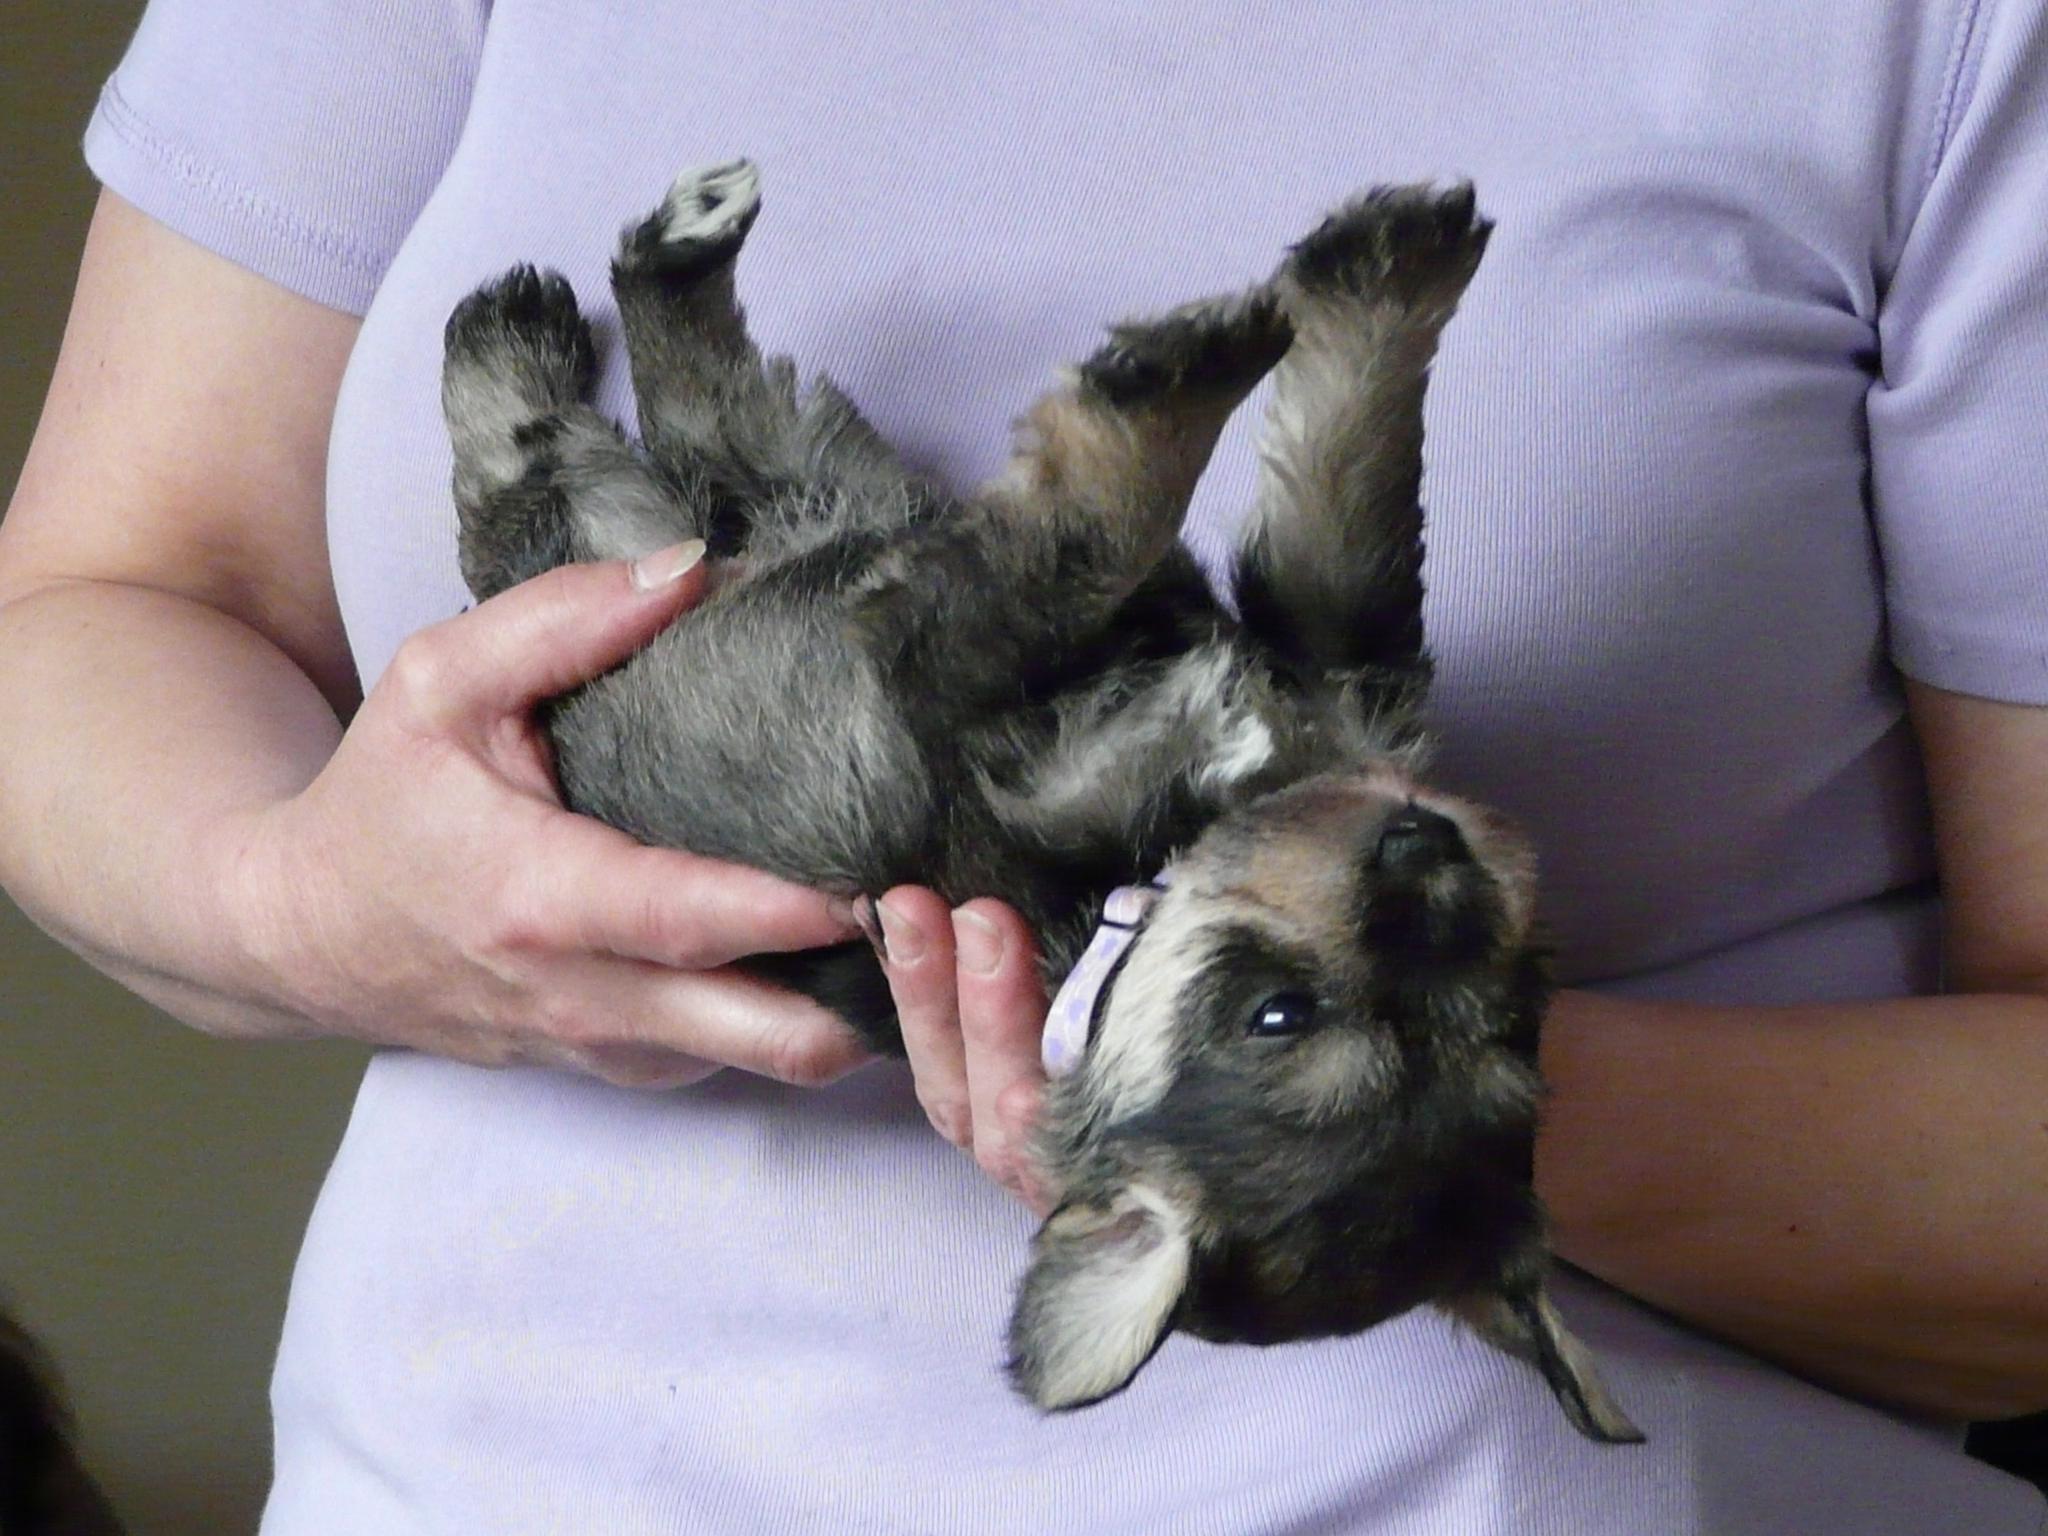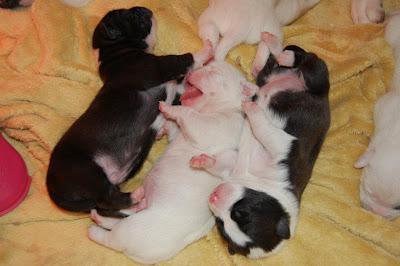The first image is the image on the left, the second image is the image on the right. For the images shown, is this caption "An image shows a mother dog in a wood-sided crate with several puppies." true? Answer yes or no. No. The first image is the image on the left, the second image is the image on the right. Analyze the images presented: Is the assertion "A wooden box with pink blankets is full of puppies" valid? Answer yes or no. No. 